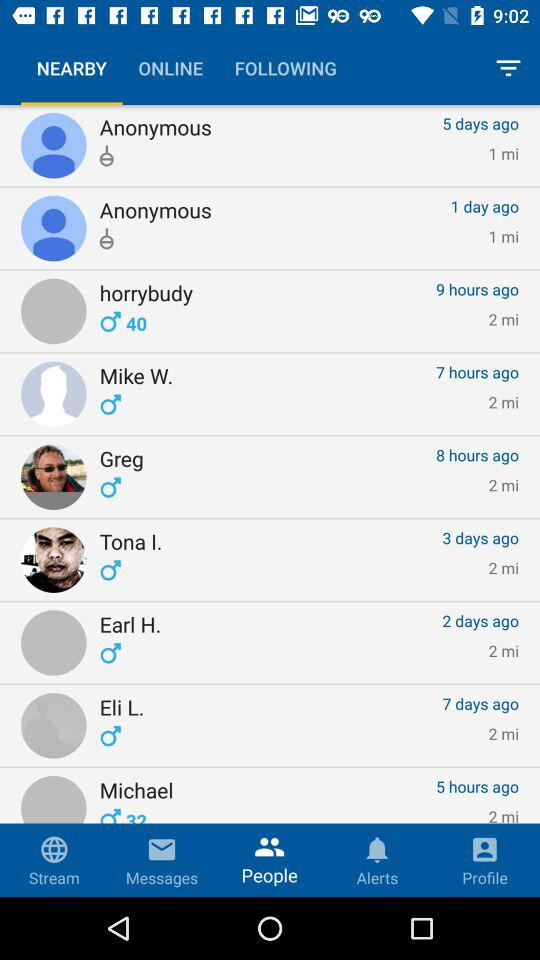What is the distance between Tona I. and where I am? The distance between Tona I. and where you are is 2 miles. 